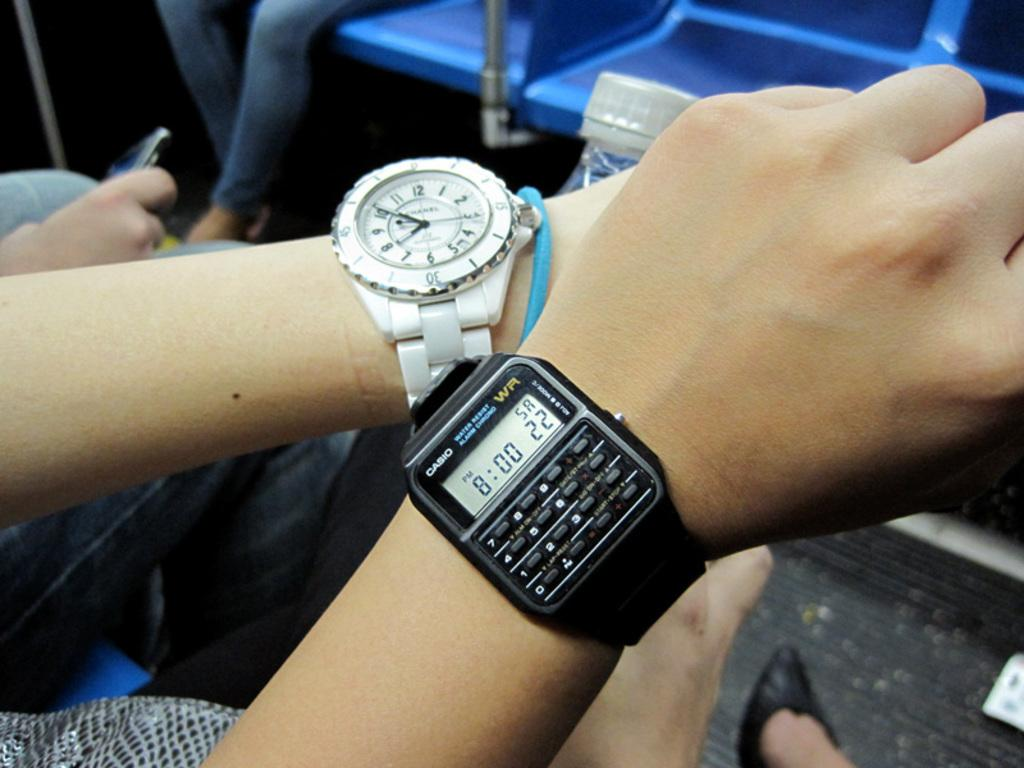<image>
Create a compact narrative representing the image presented. the time is 8:00 on the watch of a person 